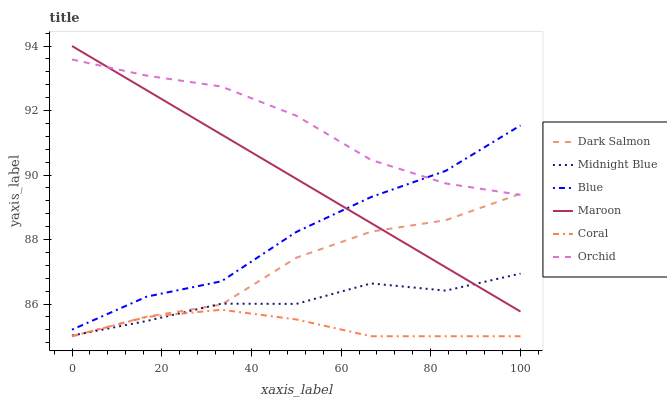Does Coral have the minimum area under the curve?
Answer yes or no. Yes. Does Orchid have the maximum area under the curve?
Answer yes or no. Yes. Does Midnight Blue have the minimum area under the curve?
Answer yes or no. No. Does Midnight Blue have the maximum area under the curve?
Answer yes or no. No. Is Maroon the smoothest?
Answer yes or no. Yes. Is Blue the roughest?
Answer yes or no. Yes. Is Midnight Blue the smoothest?
Answer yes or no. No. Is Midnight Blue the roughest?
Answer yes or no. No. Does Coral have the lowest value?
Answer yes or no. Yes. Does Midnight Blue have the lowest value?
Answer yes or no. No. Does Maroon have the highest value?
Answer yes or no. Yes. Does Midnight Blue have the highest value?
Answer yes or no. No. Is Dark Salmon less than Blue?
Answer yes or no. Yes. Is Orchid greater than Coral?
Answer yes or no. Yes. Does Orchid intersect Maroon?
Answer yes or no. Yes. Is Orchid less than Maroon?
Answer yes or no. No. Is Orchid greater than Maroon?
Answer yes or no. No. Does Dark Salmon intersect Blue?
Answer yes or no. No. 